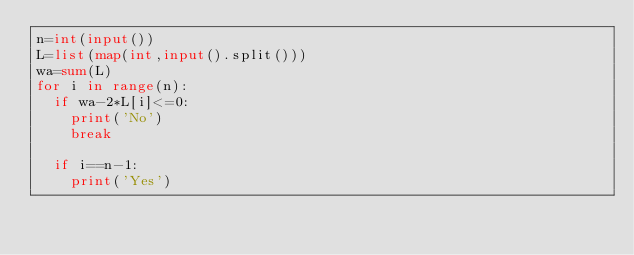Convert code to text. <code><loc_0><loc_0><loc_500><loc_500><_Python_>n=int(input())
L=list(map(int,input().split()))
wa=sum(L)
for i in range(n):
  if wa-2*L[i]<=0:
    print('No')
    break
    
  if i==n-1:
    print('Yes')
  
</code> 